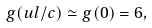Convert formula to latex. <formula><loc_0><loc_0><loc_500><loc_500>g ( u l / c ) \simeq g ( 0 ) = 6 ,</formula> 